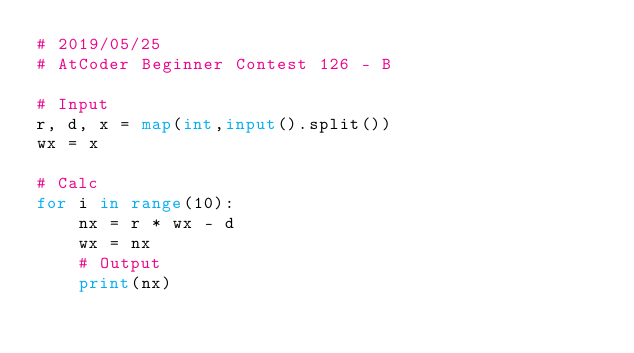Convert code to text. <code><loc_0><loc_0><loc_500><loc_500><_Python_># 2019/05/25
# AtCoder Beginner Contest 126 - B

# Input
r, d, x = map(int,input().split())
wx = x

# Calc
for i in range(10):
    nx = r * wx - d
    wx = nx
    # Output
    print(nx)
</code> 